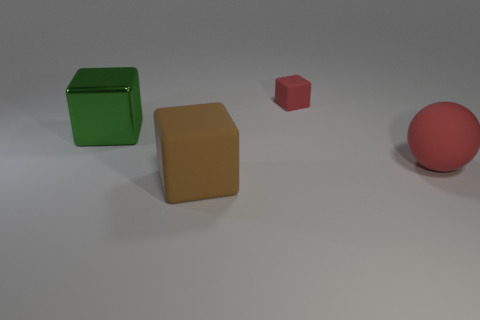Is there anything else that is the same size as the red rubber cube?
Offer a very short reply. No. How many small blue cubes have the same material as the red sphere?
Give a very brief answer. 0. The block that is the same material as the large brown object is what color?
Ensure brevity in your answer.  Red. The green metallic object has what shape?
Offer a very short reply. Cube. How many big metal cubes are the same color as the large sphere?
Provide a short and direct response. 0. There is a metallic thing that is the same size as the brown block; what is its shape?
Make the answer very short. Cube. Are there any matte things that have the same size as the green metallic cube?
Provide a short and direct response. Yes. What is the material of the brown cube that is the same size as the matte sphere?
Make the answer very short. Rubber. What is the size of the red rubber thing that is to the right of the rubber block that is behind the matte sphere?
Offer a terse response. Large. There is a block that is in front of the metallic block; is its size the same as the red matte ball?
Ensure brevity in your answer.  Yes. 